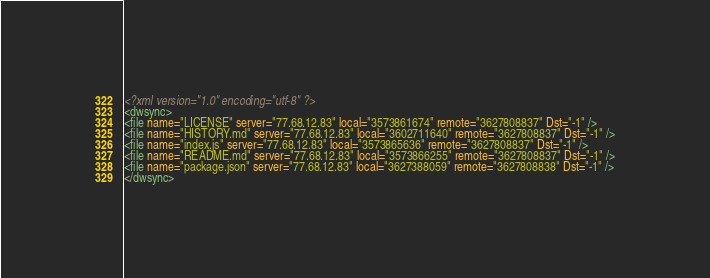Convert code to text. <code><loc_0><loc_0><loc_500><loc_500><_XML_><?xml version="1.0" encoding="utf-8" ?><dwsync><file name="LICENSE" server="77.68.12.83" local="3573861674" remote="3627808837" Dst="-1" /><file name="HISTORY.md" server="77.68.12.83" local="3602711640" remote="3627808837" Dst="-1" /><file name="index.js" server="77.68.12.83" local="3573865636" remote="3627808837" Dst="-1" /><file name="README.md" server="77.68.12.83" local="3573866255" remote="3627808837" Dst="-1" /><file name="package.json" server="77.68.12.83" local="3627388059" remote="3627808838" Dst="-1" /></dwsync></code> 